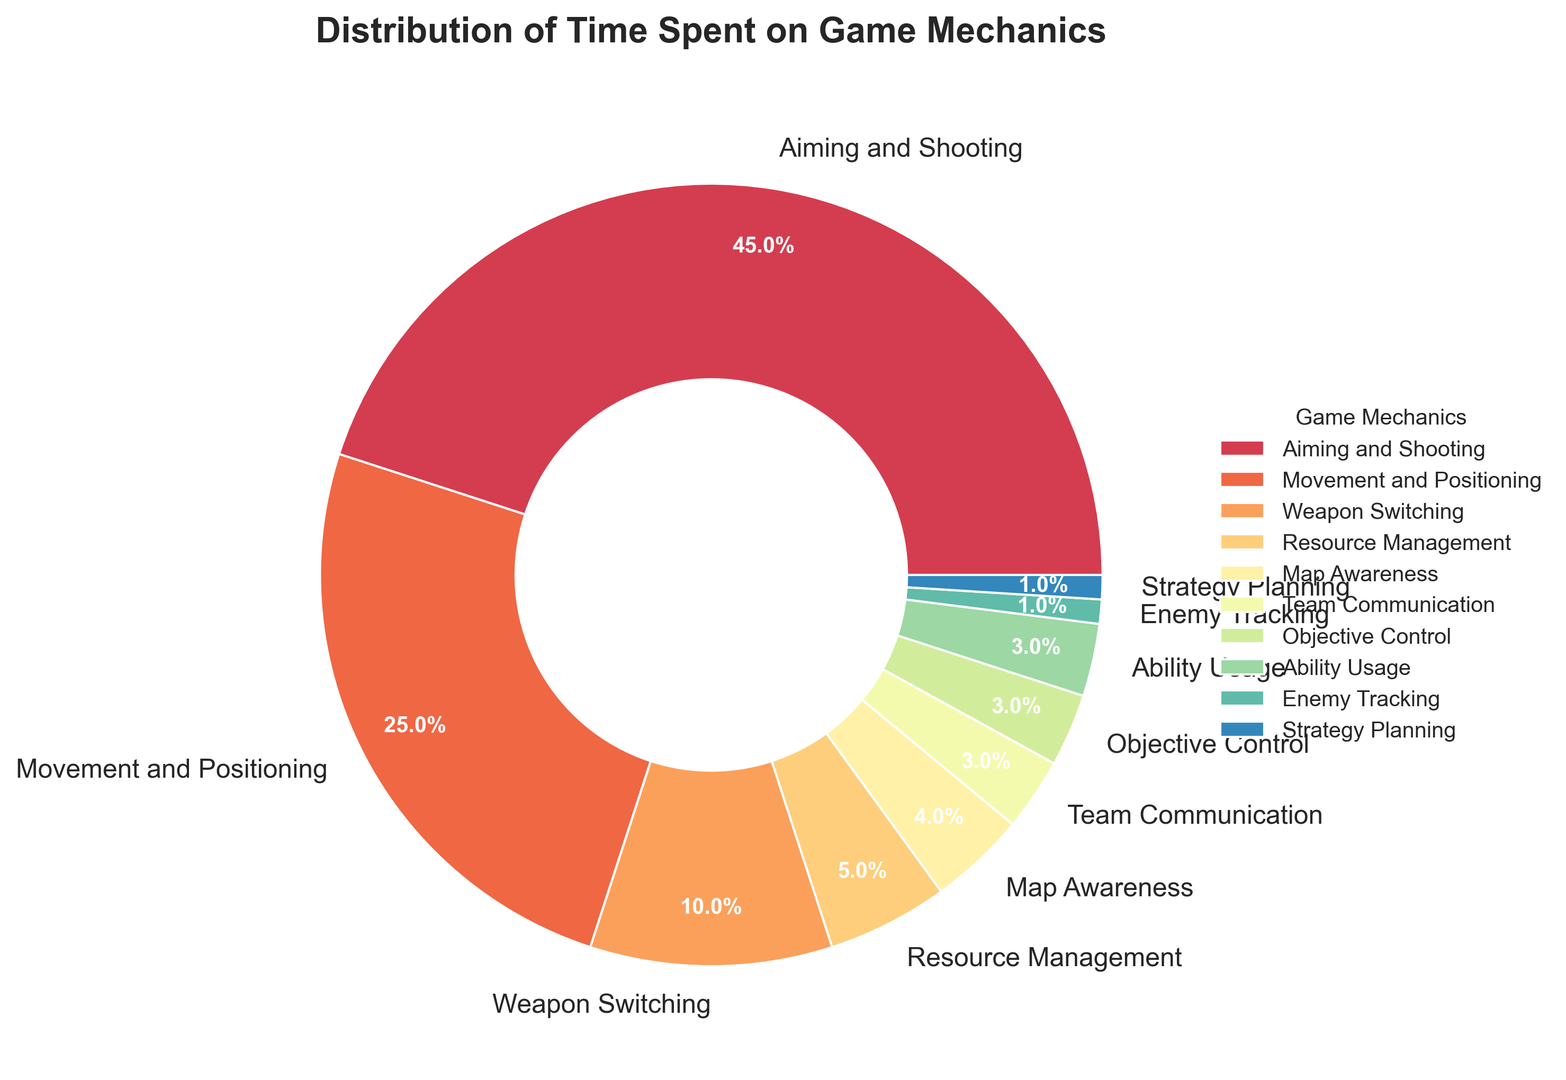Which game mechanic has the highest percentage? By looking at the pie chart, the largest wedge represents the game mechanic with the highest percentage. This wedge is labeled "Aiming and Shooting" and shows 45%.
Answer: Aiming and Shooting Which two game mechanics combined account for the majority of time spent? To find the combined total, identify the two largest segments of the pie chart. "Aiming and Shooting" has 45% and "Movement and Positioning" has 25%. Together, they account for 45% + 25% = 70%.
Answer: Aiming and Shooting and Movement and Positioning How much more time is spent on Aiming and Shooting compared to Movement and Positioning? Identify the percentages for both mechanics: Aiming and Shooting is 45%, Movement and Positioning is 25%. The difference is 45% - 25% = 20%.
Answer: 20% What is the total time spent on game mechanics that individually account for 3% or less? Identify and sum the percentages of mechanics with 3% or less: Team Communication (3%), Objective Control (3%), Ability Usage (3%), Enemy Tracking (1%), and Strategy Planning (1%). Adding them up: 3% + 3% + 3% + 1% + 1% = 11%.
Answer: 11% Which game mechanic represents the smallest portion of time spent? Find the smallest wedge in the pie chart. The smallest wedge represents "Enemy Tracking" and "Strategy Planning" both tied at 1%.
Answer: Enemy Tracking and Strategy Planning How many game mechanics individually account for less than 5% of the total time? Count the wedges with percentages less than 5%. These are Resource Management (5%), Map Awareness (4%), Team Communication (3%), Objective Control (3%), Ability Usage (3%), Enemy Tracking (1%), and Strategy Planning (1%). There are 7 such mechanics.
Answer: 7 Which game mechanic is depicted using the brightest color? Colors can vary, but the legend and the visual prominence can assist. The brightest color likely stands out the most, so look for a lighter or more intense color among the wedges.
Answer: Varies (depending on color scheme) How much more time is spent on Movement and Positioning than on Weapon Switching? Identify the percentages for both: Movement and Positioning is 25%, and Weapon Switching is 10%. The difference is 25% - 10% = 15%.
Answer: 15% Which game mechanic has a roughly equal time spent as Resource Management? Resource Management accounts for 5%. Compare this with other wedges: Map Awareness is 4%, Team Communication is 3%, Objective Control is 3%, Ability Usage is 3%. The closest is Map Awareness with 4%.
Answer: Map Awareness What percentage of time is allocated to Objective Control, Ability Usage, and Team Communication combined? Identify the percentages for each: Objective Control (3%), Ability Usage (3%), and Team Communication (3%). Summing these up: 3% + 3% + 3% = 9%.
Answer: 9% 